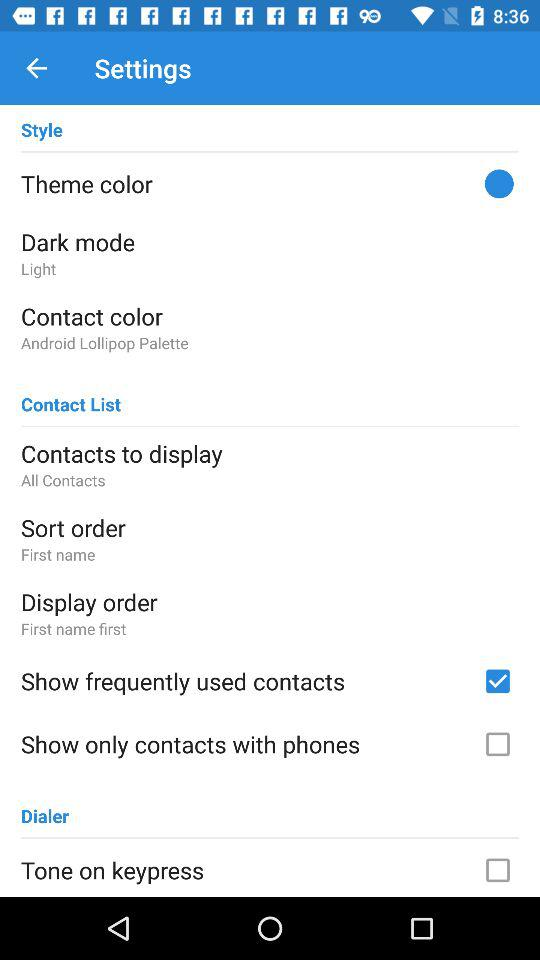What is the status of "Show frequently used contacts"? The status of "Show frequently used contacts" is "on". 